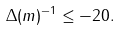Convert formula to latex. <formula><loc_0><loc_0><loc_500><loc_500>\Delta ( m ) ^ { - 1 } \leq - 2 0 .</formula> 